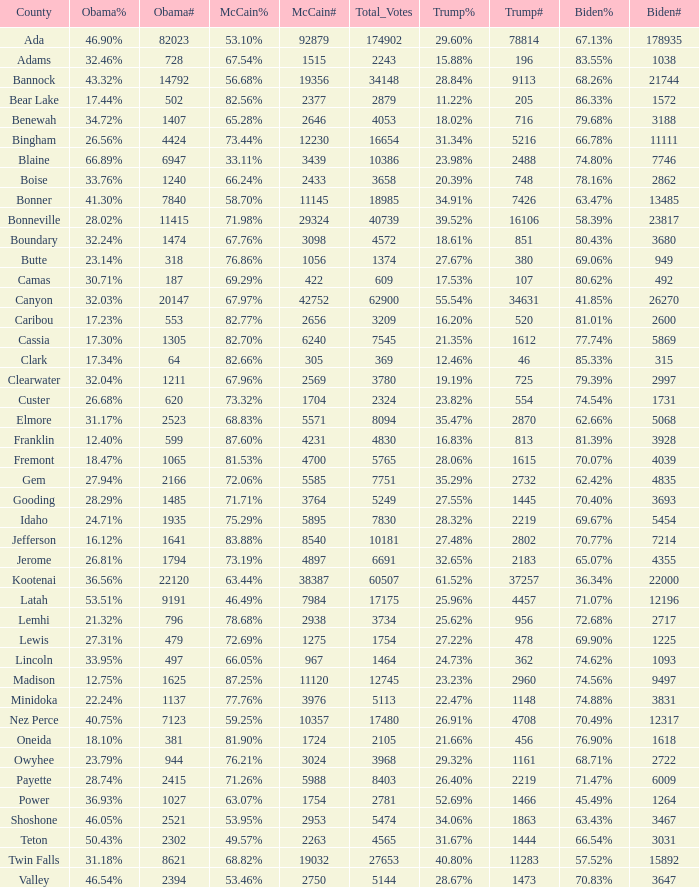For Gem County, what was the Obama vote percentage? 27.94%. 